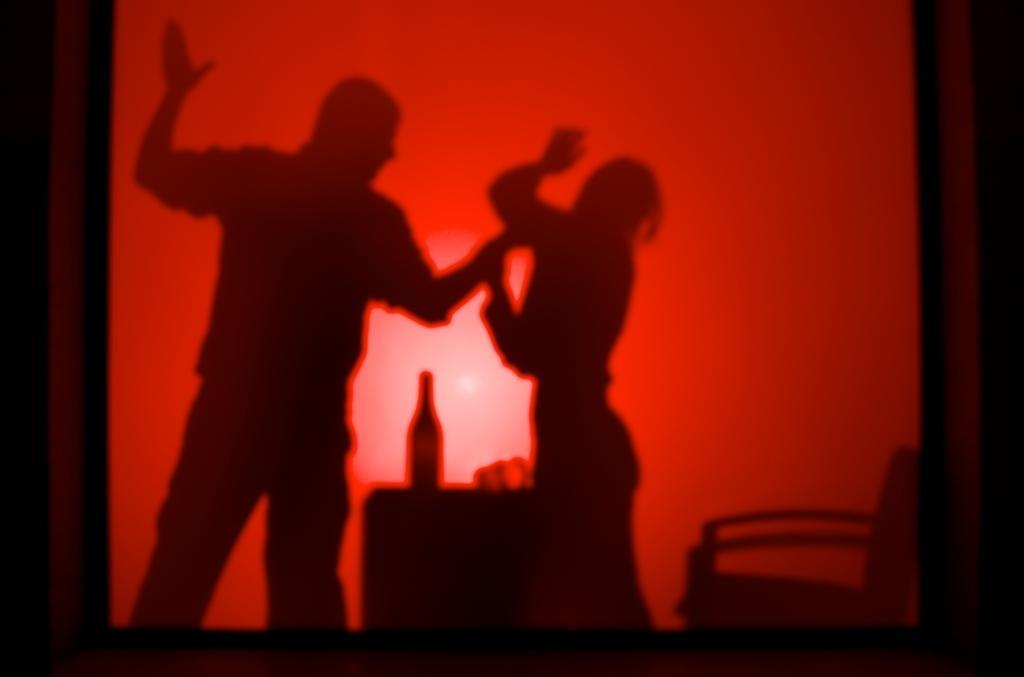In one or two sentences, can you explain what this image depicts? In the center there is a red color object on which we can see the shadow of the chair and two persons standing and we can see the shadow of some items which are placed on the top of the table. 